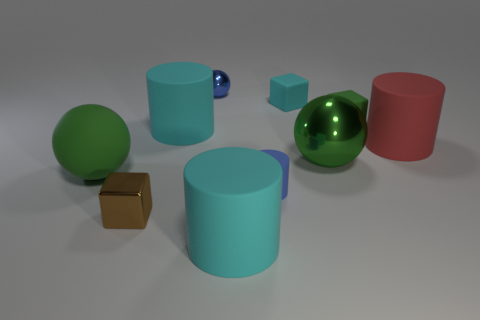Can you describe the shapes of the objects seen in the image? Certainly! There are cylindrical objects, one sphere, a cube, and one object resembling a capsule or pill shape. How can the concept of symmetry be observed in this image? Many of the objects exhibit symmetry. The cylindrical cups are symmetric around their central axis, the sphere has infinite planes of symmetry, and the cube has symmetrical faces relative to its center point. 